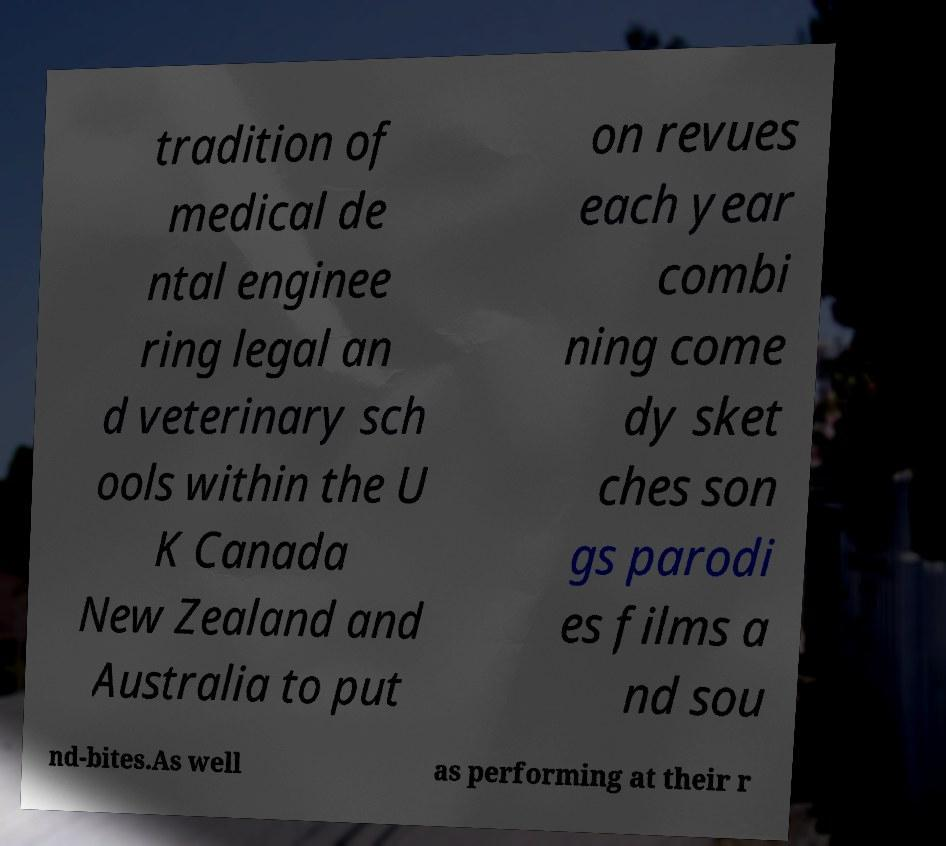Could you extract and type out the text from this image? tradition of medical de ntal enginee ring legal an d veterinary sch ools within the U K Canada New Zealand and Australia to put on revues each year combi ning come dy sket ches son gs parodi es films a nd sou nd-bites.As well as performing at their r 